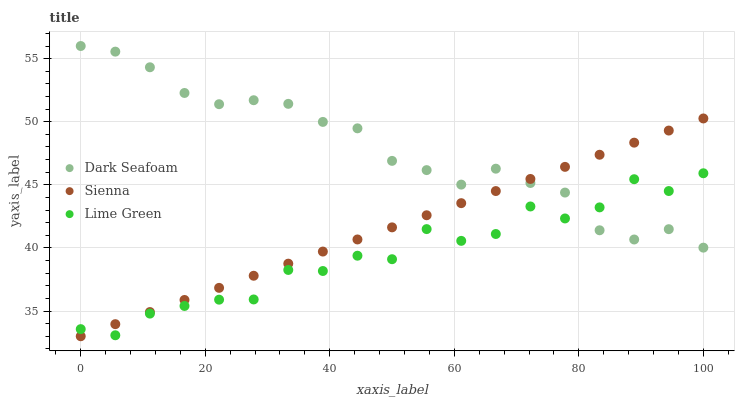Does Lime Green have the minimum area under the curve?
Answer yes or no. Yes. Does Dark Seafoam have the maximum area under the curve?
Answer yes or no. Yes. Does Dark Seafoam have the minimum area under the curve?
Answer yes or no. No. Does Lime Green have the maximum area under the curve?
Answer yes or no. No. Is Sienna the smoothest?
Answer yes or no. Yes. Is Lime Green the roughest?
Answer yes or no. Yes. Is Dark Seafoam the smoothest?
Answer yes or no. No. Is Dark Seafoam the roughest?
Answer yes or no. No. Does Sienna have the lowest value?
Answer yes or no. Yes. Does Lime Green have the lowest value?
Answer yes or no. No. Does Dark Seafoam have the highest value?
Answer yes or no. Yes. Does Lime Green have the highest value?
Answer yes or no. No. Does Lime Green intersect Dark Seafoam?
Answer yes or no. Yes. Is Lime Green less than Dark Seafoam?
Answer yes or no. No. Is Lime Green greater than Dark Seafoam?
Answer yes or no. No. 